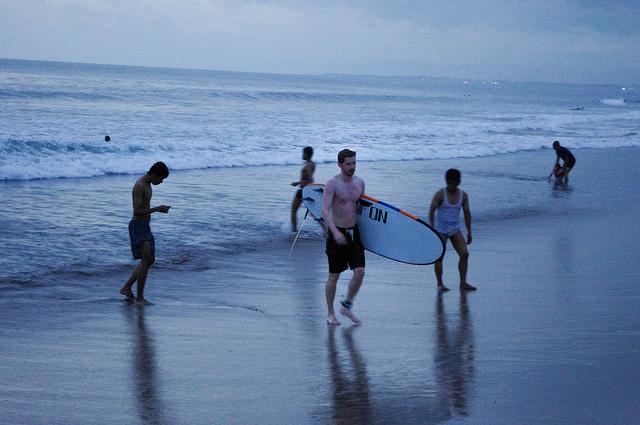Do both people have knots on their shirts?
Keep it brief. No. How many people are carrying surfboards?
Short answer required. 1. Which swimmer has the palest skin?
Short answer required. Front one. How many people are holding a surfboard?
Concise answer only. 1. Is the beach crowded?
Quick response, please. No. Are there more men than women on the beach?
Be succinct. Yes. Are they all barefoot?
Keep it brief. Yes. 